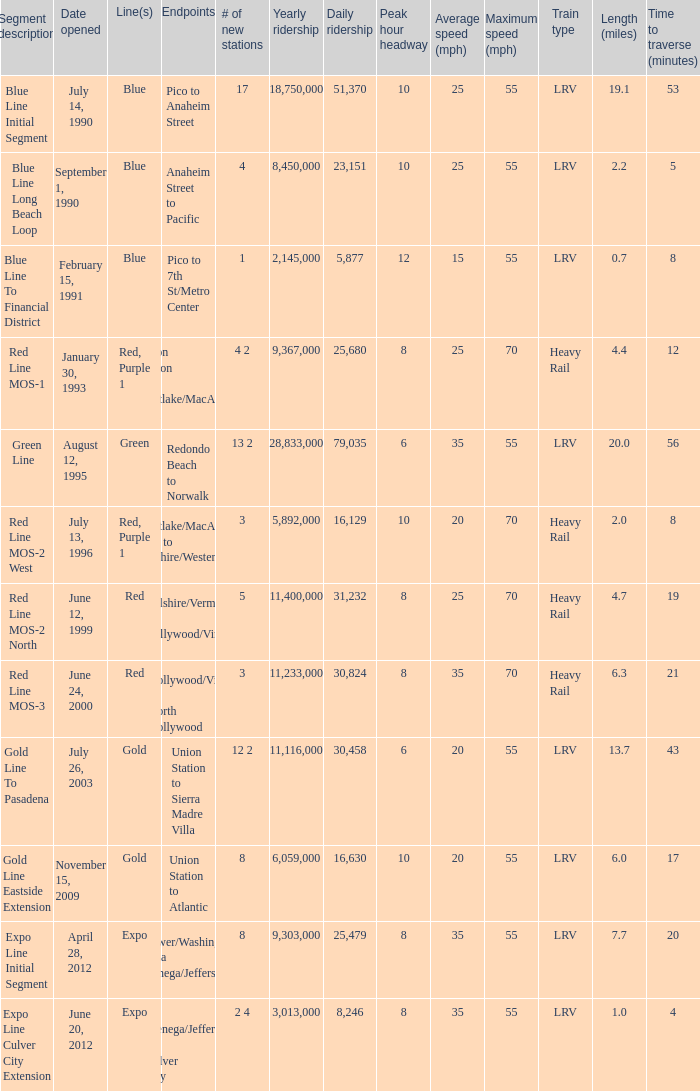How many new stations have a lenght (miles) of 6.0? 1.0. 